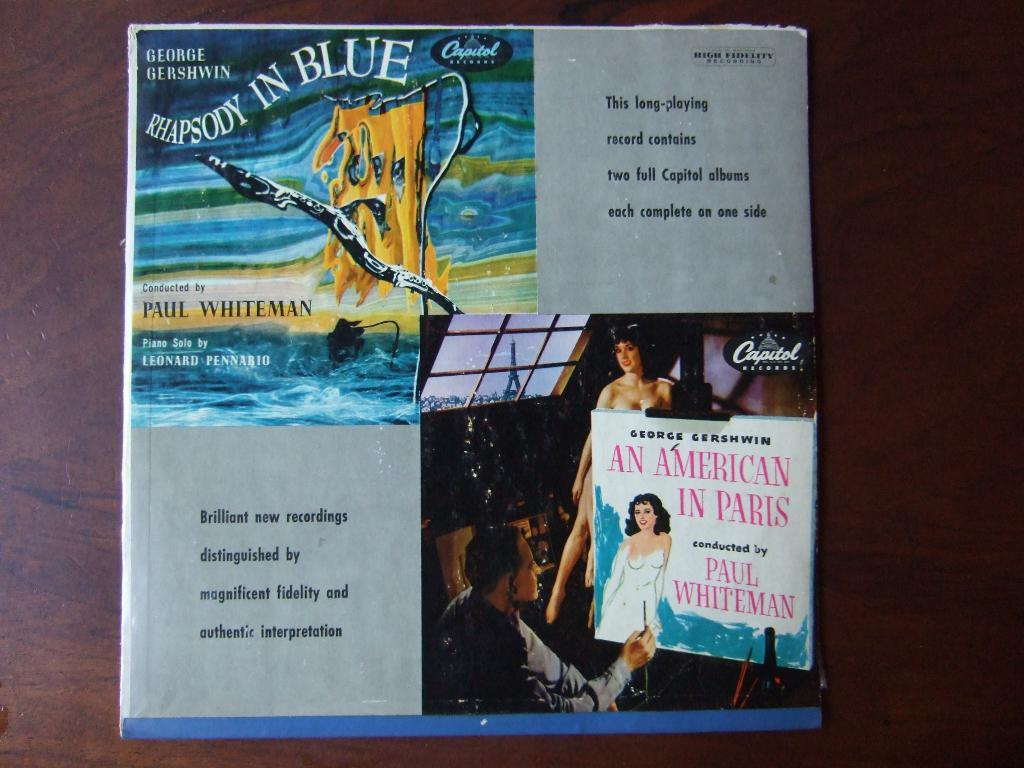<image>
Give a short and clear explanation of the subsequent image. An album cover that it Titled Rhapsody in Blue. 